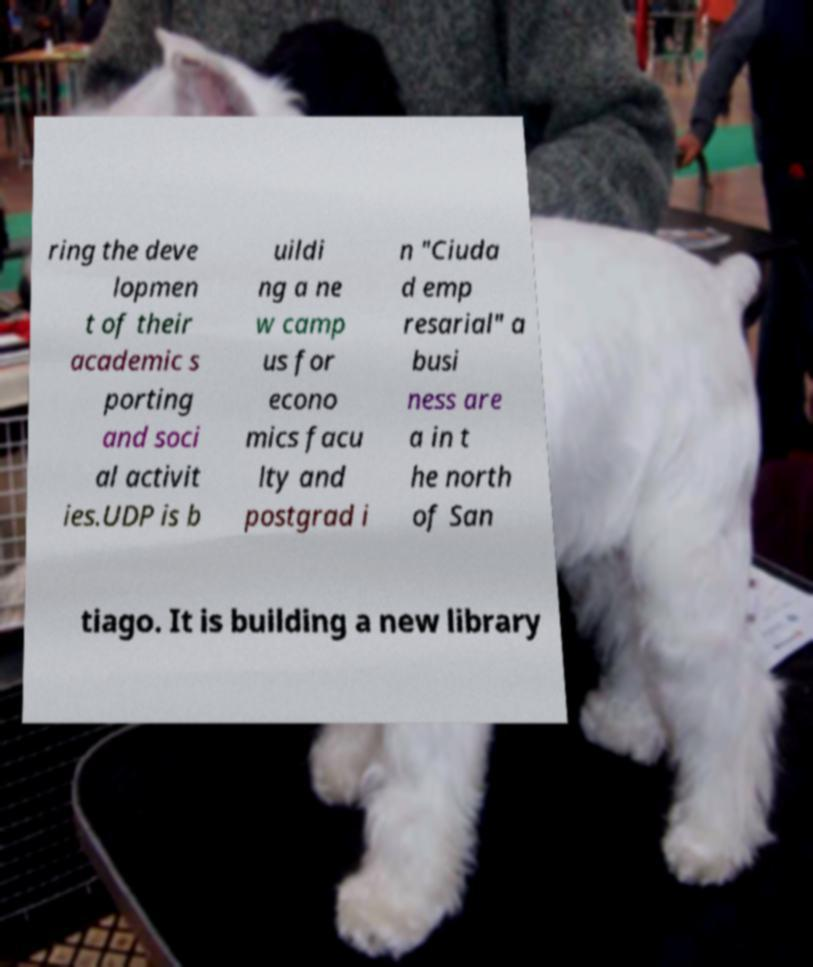There's text embedded in this image that I need extracted. Can you transcribe it verbatim? ring the deve lopmen t of their academic s porting and soci al activit ies.UDP is b uildi ng a ne w camp us for econo mics facu lty and postgrad i n "Ciuda d emp resarial" a busi ness are a in t he north of San tiago. It is building a new library 